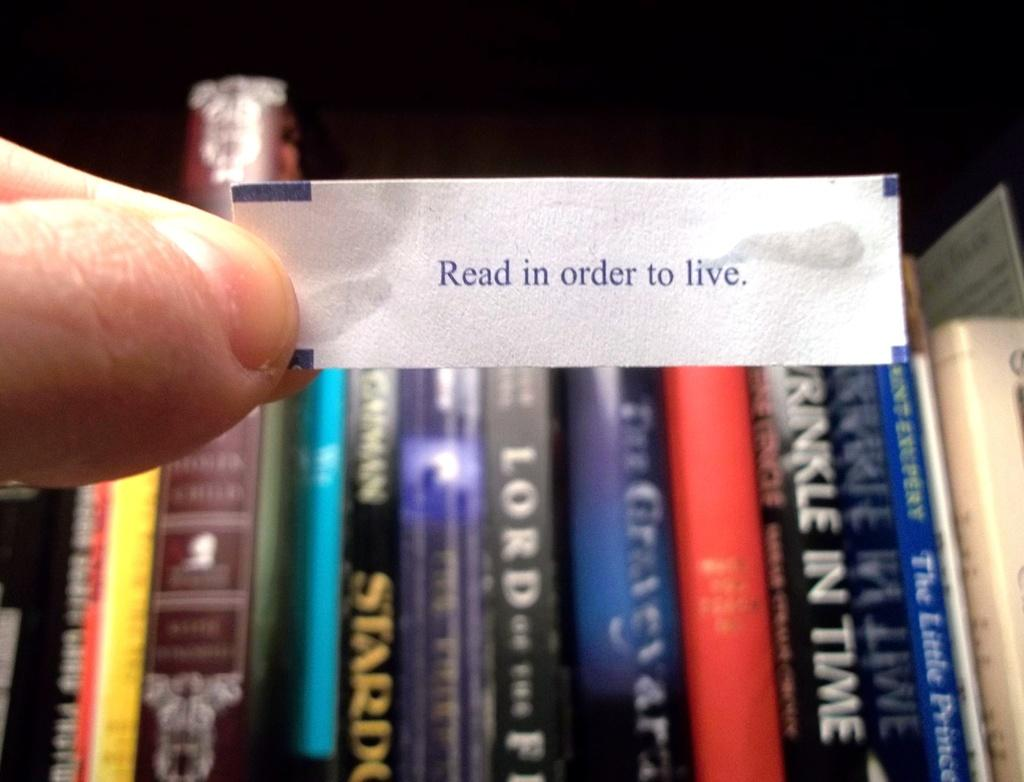What is the person in the image holding? There is a hand holding a paper in the image. What can be seen on the paper? The paper has text on it. What is visible in the background of the image? There are books in the background of the image. How are the books arranged? The books are arranged one beside the other. Can you hear the jellyfish coughing in the image? There are no jellyfish or sounds in the image, so it is not possible to hear a jellyfish coughing. 